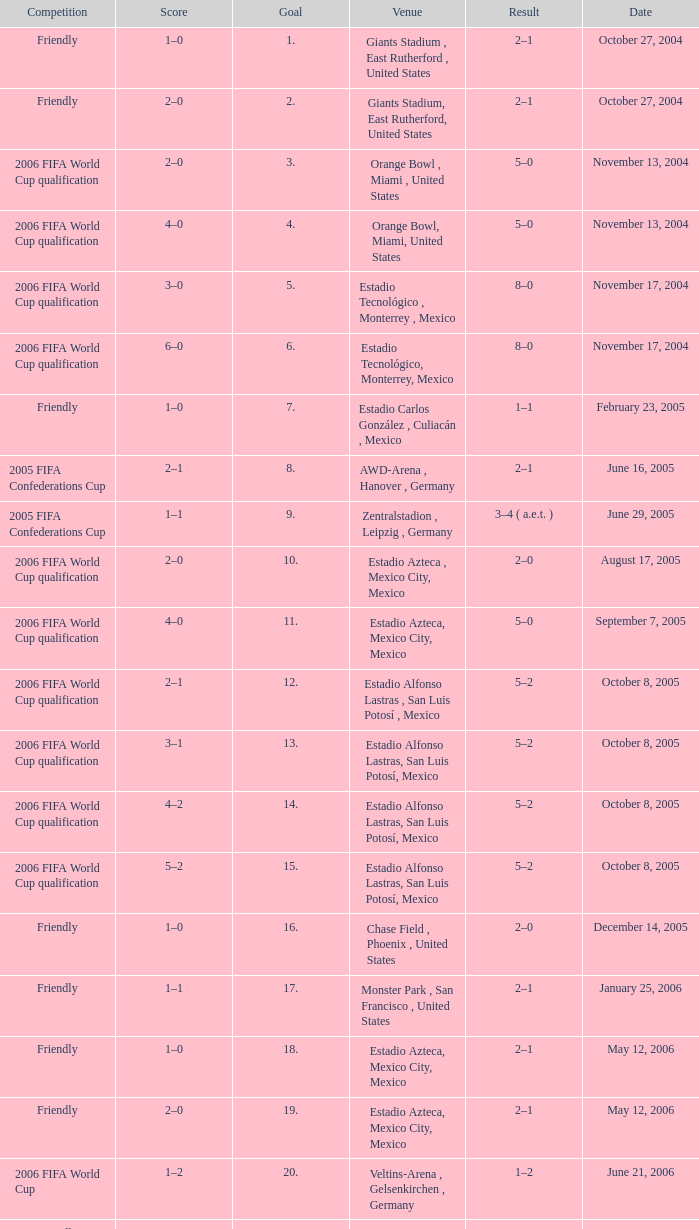Which Score has a Result of 2–1, and a Competition of friendly, and a Goal smaller than 17? 1–0, 2–0. 